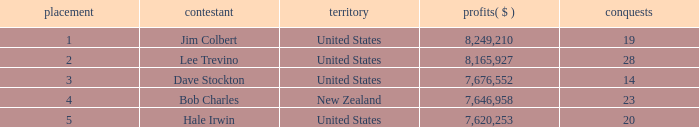How many average wins for players ranked below 2 with earnings greater than $7,676,552? None. 